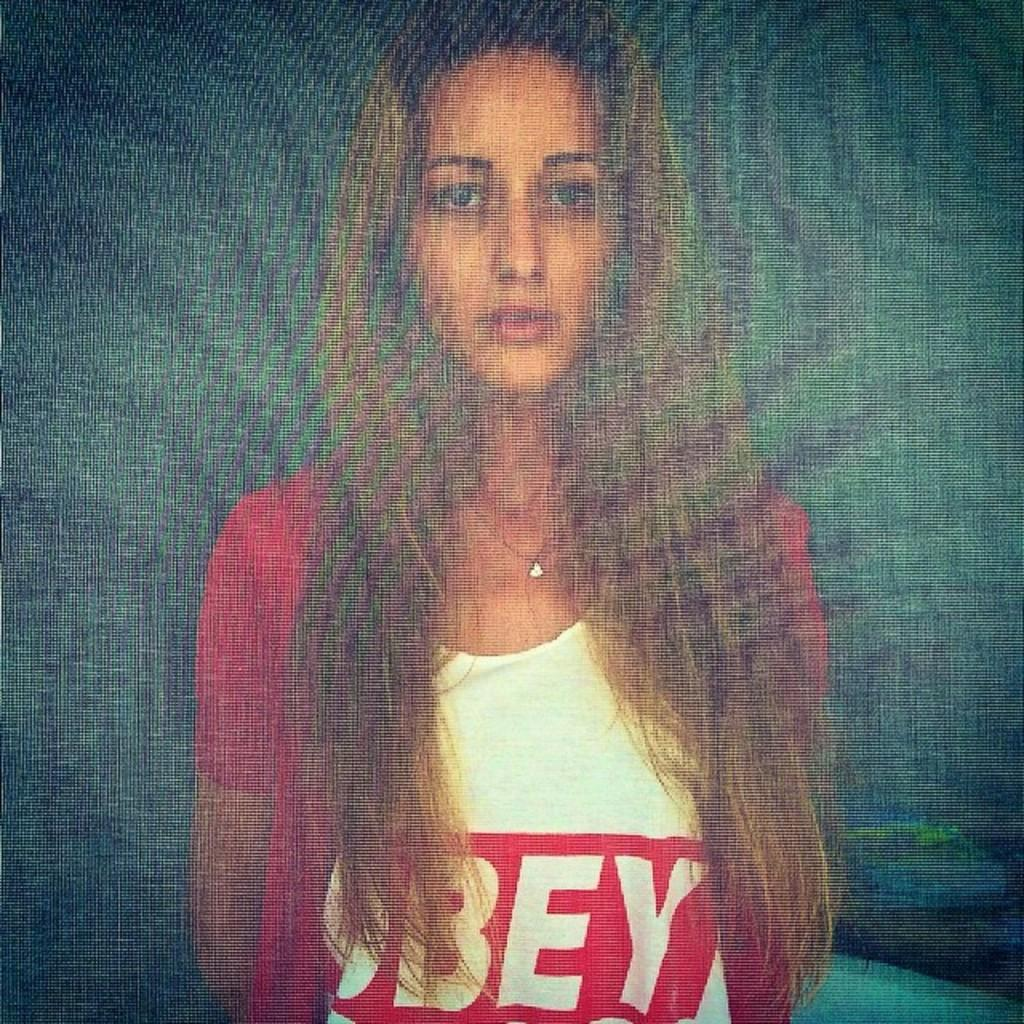What is the overall quality of the image? The image is blurry. Can you identify any people in the image? Yes, there is a woman in the image. What type of discussion is taking place between the woman and the brick in the image? There is no brick present in the image, and therefore no discussion can be observed. 